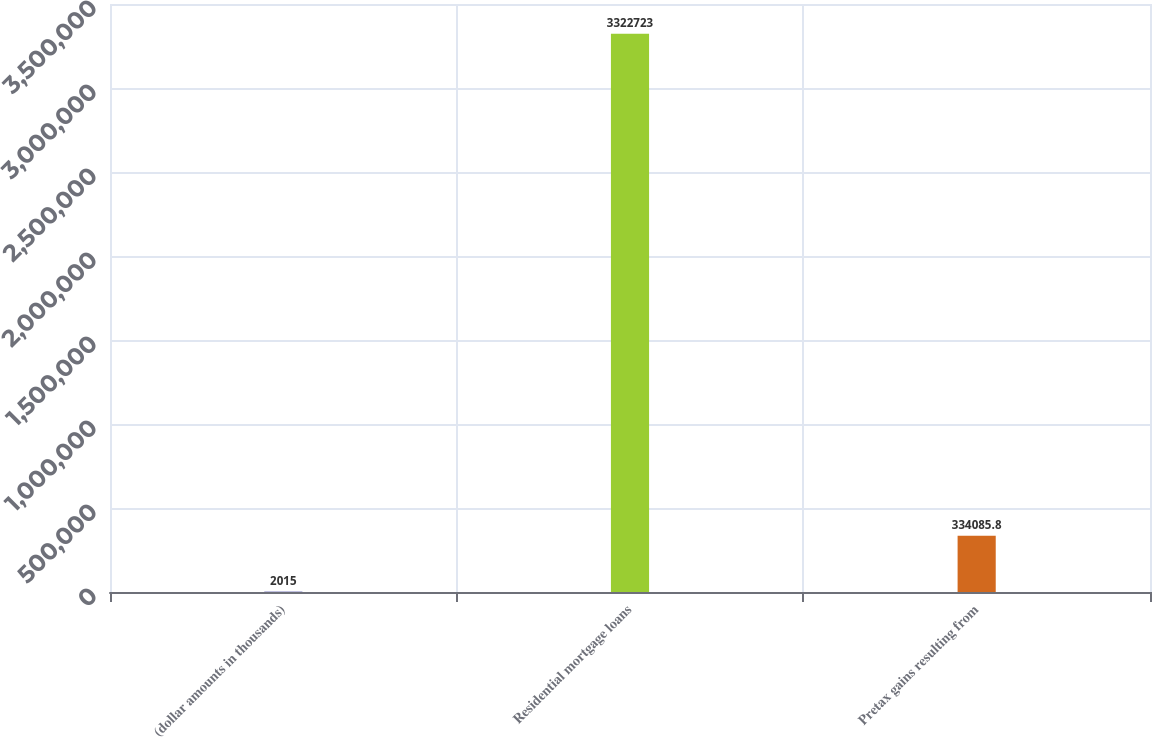Convert chart to OTSL. <chart><loc_0><loc_0><loc_500><loc_500><bar_chart><fcel>(dollar amounts in thousands)<fcel>Residential mortgage loans<fcel>Pretax gains resulting from<nl><fcel>2015<fcel>3.32272e+06<fcel>334086<nl></chart> 